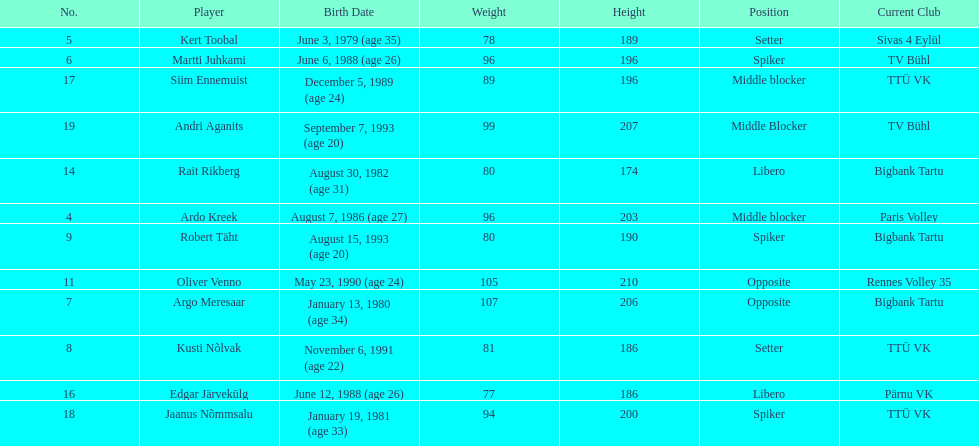Which player is taller than andri agantis? Oliver Venno. Can you give me this table as a dict? {'header': ['No.', 'Player', 'Birth Date', 'Weight', 'Height', 'Position', 'Current Club'], 'rows': [['5', 'Kert Toobal', 'June 3, 1979 (age\xa035)', '78', '189', 'Setter', 'Sivas 4 Eylül'], ['6', 'Martti Juhkami', 'June 6, 1988 (age\xa026)', '96', '196', 'Spiker', 'TV Bühl'], ['17', 'Siim Ennemuist', 'December 5, 1989 (age\xa024)', '89', '196', 'Middle blocker', 'TTÜ VK'], ['19', 'Andri Aganits', 'September 7, 1993 (age\xa020)', '99', '207', 'Middle Blocker', 'TV Bühl'], ['14', 'Rait Rikberg', 'August 30, 1982 (age\xa031)', '80', '174', 'Libero', 'Bigbank Tartu'], ['4', 'Ardo Kreek', 'August 7, 1986 (age\xa027)', '96', '203', 'Middle blocker', 'Paris Volley'], ['9', 'Robert Täht', 'August 15, 1993 (age\xa020)', '80', '190', 'Spiker', 'Bigbank Tartu'], ['11', 'Oliver Venno', 'May 23, 1990 (age\xa024)', '105', '210', 'Opposite', 'Rennes Volley 35'], ['7', 'Argo Meresaar', 'January 13, 1980 (age\xa034)', '107', '206', 'Opposite', 'Bigbank Tartu'], ['8', 'Kusti Nõlvak', 'November 6, 1991 (age\xa022)', '81', '186', 'Setter', 'TTÜ VK'], ['16', 'Edgar Järvekülg', 'June 12, 1988 (age\xa026)', '77', '186', 'Libero', 'Pärnu VK'], ['18', 'Jaanus Nõmmsalu', 'January 19, 1981 (age\xa033)', '94', '200', 'Spiker', 'TTÜ VK']]} 